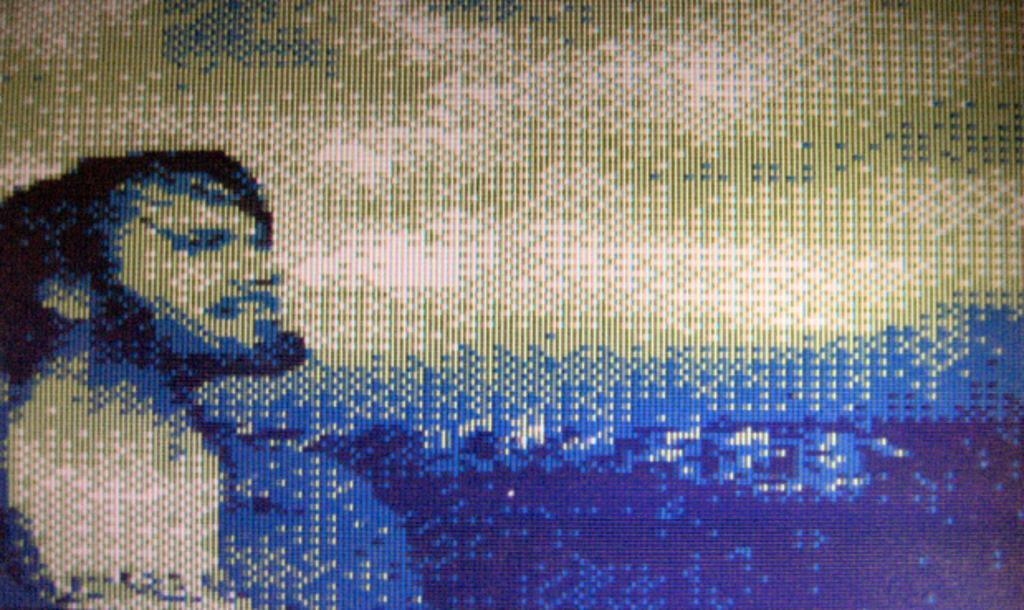Can you describe this image briefly? This is an edited picture. In the foreground there is a man. At the back there might be trees. 